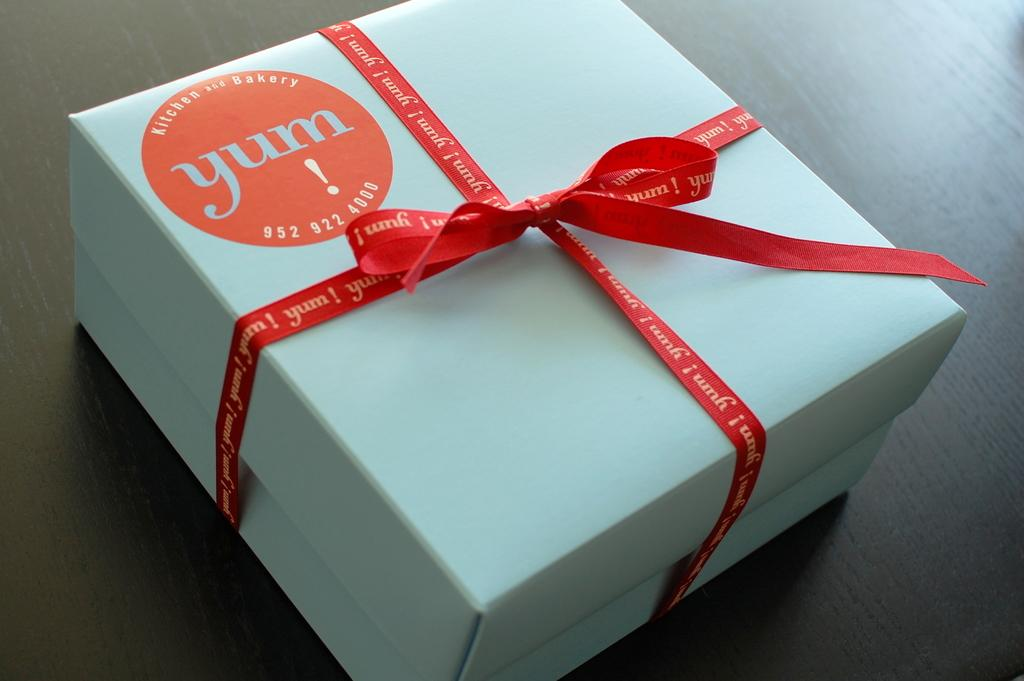<image>
Describe the image concisely. a white box with a red sticker on it that says 'yum!' on it 